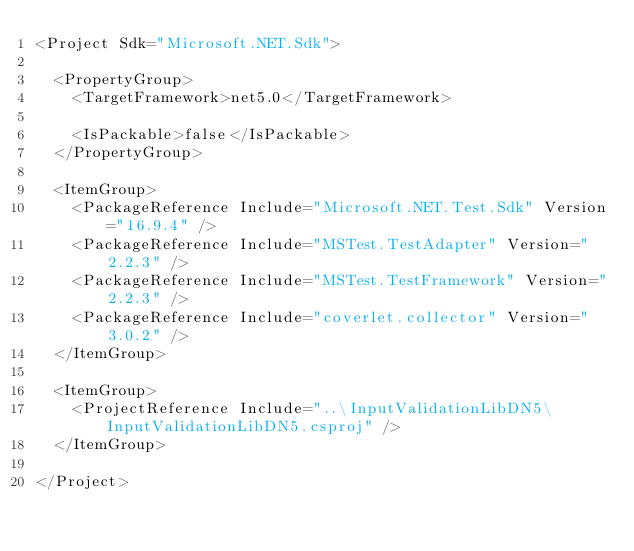<code> <loc_0><loc_0><loc_500><loc_500><_XML_><Project Sdk="Microsoft.NET.Sdk">

  <PropertyGroup>
    <TargetFramework>net5.0</TargetFramework>

    <IsPackable>false</IsPackable>
  </PropertyGroup>

  <ItemGroup>
    <PackageReference Include="Microsoft.NET.Test.Sdk" Version="16.9.4" />
    <PackageReference Include="MSTest.TestAdapter" Version="2.2.3" />
    <PackageReference Include="MSTest.TestFramework" Version="2.2.3" />
    <PackageReference Include="coverlet.collector" Version="3.0.2" />
  </ItemGroup>

  <ItemGroup>
    <ProjectReference Include="..\InputValidationLibDN5\InputValidationLibDN5.csproj" />
  </ItemGroup>

</Project>
</code> 